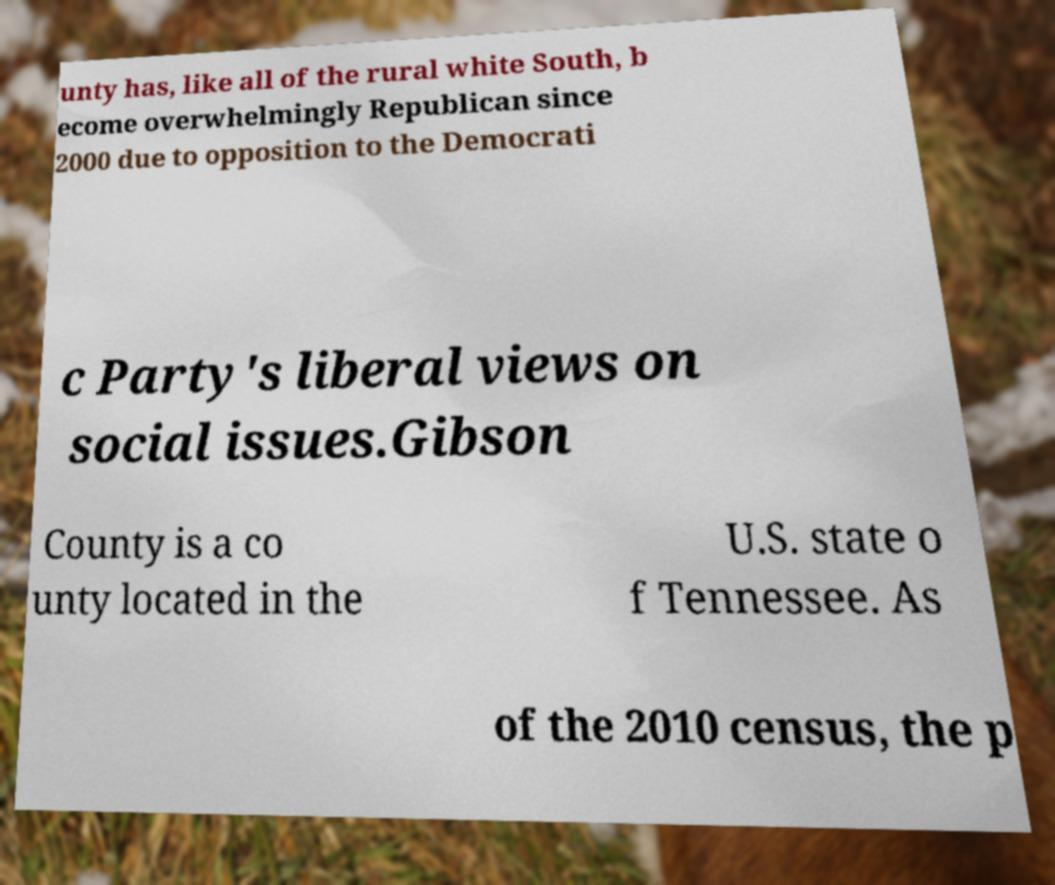Can you accurately transcribe the text from the provided image for me? unty has, like all of the rural white South, b ecome overwhelmingly Republican since 2000 due to opposition to the Democrati c Party's liberal views on social issues.Gibson County is a co unty located in the U.S. state o f Tennessee. As of the 2010 census, the p 